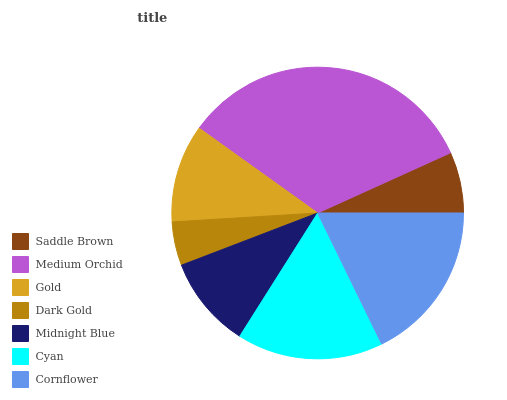Is Dark Gold the minimum?
Answer yes or no. Yes. Is Medium Orchid the maximum?
Answer yes or no. Yes. Is Gold the minimum?
Answer yes or no. No. Is Gold the maximum?
Answer yes or no. No. Is Medium Orchid greater than Gold?
Answer yes or no. Yes. Is Gold less than Medium Orchid?
Answer yes or no. Yes. Is Gold greater than Medium Orchid?
Answer yes or no. No. Is Medium Orchid less than Gold?
Answer yes or no. No. Is Gold the high median?
Answer yes or no. Yes. Is Gold the low median?
Answer yes or no. Yes. Is Saddle Brown the high median?
Answer yes or no. No. Is Dark Gold the low median?
Answer yes or no. No. 